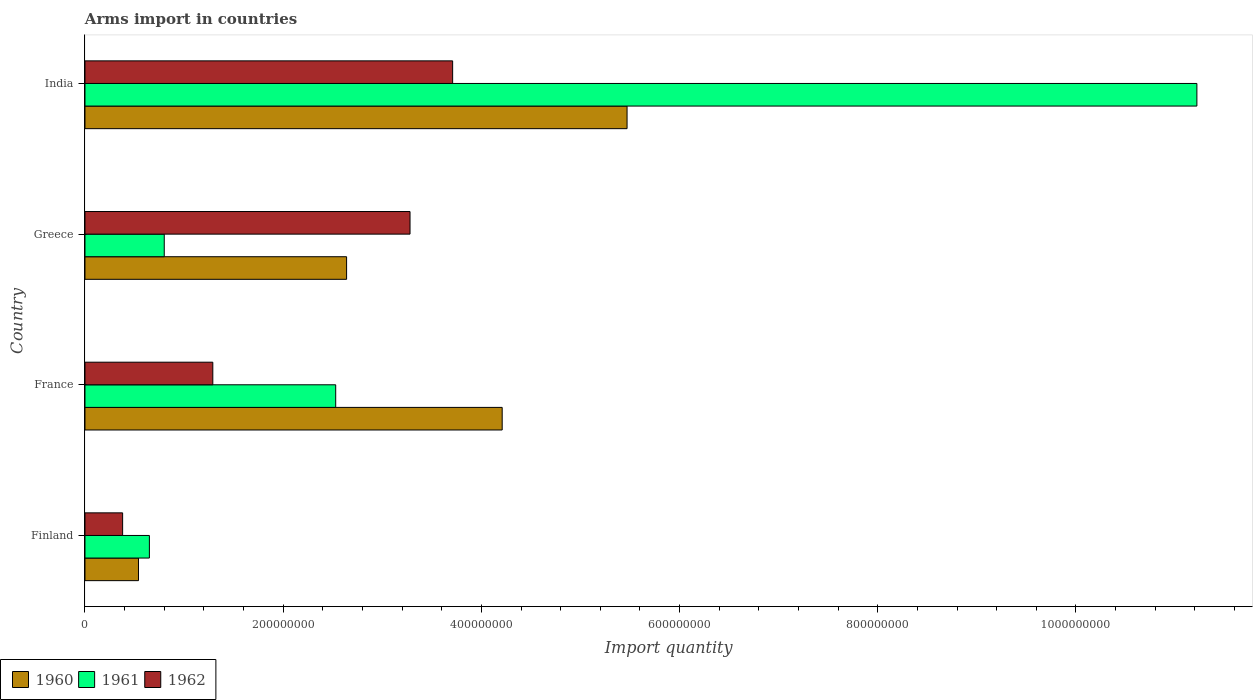How many bars are there on the 4th tick from the bottom?
Make the answer very short. 3. What is the label of the 1st group of bars from the top?
Your answer should be very brief. India. In how many cases, is the number of bars for a given country not equal to the number of legend labels?
Your response must be concise. 0. What is the total arms import in 1960 in France?
Your answer should be very brief. 4.21e+08. Across all countries, what is the maximum total arms import in 1961?
Provide a succinct answer. 1.12e+09. Across all countries, what is the minimum total arms import in 1960?
Offer a very short reply. 5.40e+07. In which country was the total arms import in 1961 minimum?
Offer a terse response. Finland. What is the total total arms import in 1961 in the graph?
Offer a very short reply. 1.52e+09. What is the difference between the total arms import in 1960 in Finland and that in Greece?
Give a very brief answer. -2.10e+08. What is the difference between the total arms import in 1962 in India and the total arms import in 1961 in Finland?
Offer a terse response. 3.06e+08. What is the average total arms import in 1960 per country?
Ensure brevity in your answer.  3.22e+08. What is the difference between the total arms import in 1961 and total arms import in 1962 in France?
Your answer should be compact. 1.24e+08. In how many countries, is the total arms import in 1960 greater than 680000000 ?
Offer a terse response. 0. What is the ratio of the total arms import in 1960 in France to that in India?
Your answer should be compact. 0.77. Is the difference between the total arms import in 1961 in France and India greater than the difference between the total arms import in 1962 in France and India?
Keep it short and to the point. No. What is the difference between the highest and the second highest total arms import in 1961?
Your response must be concise. 8.69e+08. What is the difference between the highest and the lowest total arms import in 1961?
Give a very brief answer. 1.06e+09. What does the 1st bar from the top in Finland represents?
Provide a succinct answer. 1962. What does the 3rd bar from the bottom in Greece represents?
Make the answer very short. 1962. Are all the bars in the graph horizontal?
Ensure brevity in your answer.  Yes. What is the difference between two consecutive major ticks on the X-axis?
Keep it short and to the point. 2.00e+08. Are the values on the major ticks of X-axis written in scientific E-notation?
Your answer should be very brief. No. Does the graph contain any zero values?
Your answer should be very brief. No. Does the graph contain grids?
Your response must be concise. No. Where does the legend appear in the graph?
Keep it short and to the point. Bottom left. How many legend labels are there?
Offer a terse response. 3. What is the title of the graph?
Your response must be concise. Arms import in countries. Does "1963" appear as one of the legend labels in the graph?
Your answer should be compact. No. What is the label or title of the X-axis?
Your answer should be very brief. Import quantity. What is the label or title of the Y-axis?
Offer a terse response. Country. What is the Import quantity in 1960 in Finland?
Provide a short and direct response. 5.40e+07. What is the Import quantity in 1961 in Finland?
Ensure brevity in your answer.  6.50e+07. What is the Import quantity of 1962 in Finland?
Your answer should be very brief. 3.80e+07. What is the Import quantity of 1960 in France?
Keep it short and to the point. 4.21e+08. What is the Import quantity of 1961 in France?
Make the answer very short. 2.53e+08. What is the Import quantity in 1962 in France?
Provide a short and direct response. 1.29e+08. What is the Import quantity of 1960 in Greece?
Your answer should be very brief. 2.64e+08. What is the Import quantity in 1961 in Greece?
Make the answer very short. 8.00e+07. What is the Import quantity in 1962 in Greece?
Offer a terse response. 3.28e+08. What is the Import quantity in 1960 in India?
Your response must be concise. 5.47e+08. What is the Import quantity of 1961 in India?
Your answer should be very brief. 1.12e+09. What is the Import quantity in 1962 in India?
Keep it short and to the point. 3.71e+08. Across all countries, what is the maximum Import quantity of 1960?
Offer a very short reply. 5.47e+08. Across all countries, what is the maximum Import quantity of 1961?
Provide a succinct answer. 1.12e+09. Across all countries, what is the maximum Import quantity in 1962?
Provide a succinct answer. 3.71e+08. Across all countries, what is the minimum Import quantity of 1960?
Provide a short and direct response. 5.40e+07. Across all countries, what is the minimum Import quantity of 1961?
Ensure brevity in your answer.  6.50e+07. Across all countries, what is the minimum Import quantity in 1962?
Keep it short and to the point. 3.80e+07. What is the total Import quantity in 1960 in the graph?
Your answer should be compact. 1.29e+09. What is the total Import quantity in 1961 in the graph?
Offer a very short reply. 1.52e+09. What is the total Import quantity of 1962 in the graph?
Offer a terse response. 8.66e+08. What is the difference between the Import quantity in 1960 in Finland and that in France?
Make the answer very short. -3.67e+08. What is the difference between the Import quantity in 1961 in Finland and that in France?
Your response must be concise. -1.88e+08. What is the difference between the Import quantity in 1962 in Finland and that in France?
Provide a succinct answer. -9.10e+07. What is the difference between the Import quantity in 1960 in Finland and that in Greece?
Keep it short and to the point. -2.10e+08. What is the difference between the Import quantity of 1961 in Finland and that in Greece?
Provide a succinct answer. -1.50e+07. What is the difference between the Import quantity of 1962 in Finland and that in Greece?
Provide a short and direct response. -2.90e+08. What is the difference between the Import quantity in 1960 in Finland and that in India?
Provide a succinct answer. -4.93e+08. What is the difference between the Import quantity in 1961 in Finland and that in India?
Your response must be concise. -1.06e+09. What is the difference between the Import quantity of 1962 in Finland and that in India?
Ensure brevity in your answer.  -3.33e+08. What is the difference between the Import quantity of 1960 in France and that in Greece?
Make the answer very short. 1.57e+08. What is the difference between the Import quantity of 1961 in France and that in Greece?
Keep it short and to the point. 1.73e+08. What is the difference between the Import quantity of 1962 in France and that in Greece?
Ensure brevity in your answer.  -1.99e+08. What is the difference between the Import quantity of 1960 in France and that in India?
Provide a succinct answer. -1.26e+08. What is the difference between the Import quantity of 1961 in France and that in India?
Keep it short and to the point. -8.69e+08. What is the difference between the Import quantity of 1962 in France and that in India?
Provide a succinct answer. -2.42e+08. What is the difference between the Import quantity in 1960 in Greece and that in India?
Provide a succinct answer. -2.83e+08. What is the difference between the Import quantity in 1961 in Greece and that in India?
Give a very brief answer. -1.04e+09. What is the difference between the Import quantity of 1962 in Greece and that in India?
Offer a terse response. -4.30e+07. What is the difference between the Import quantity in 1960 in Finland and the Import quantity in 1961 in France?
Ensure brevity in your answer.  -1.99e+08. What is the difference between the Import quantity in 1960 in Finland and the Import quantity in 1962 in France?
Offer a terse response. -7.50e+07. What is the difference between the Import quantity in 1961 in Finland and the Import quantity in 1962 in France?
Ensure brevity in your answer.  -6.40e+07. What is the difference between the Import quantity in 1960 in Finland and the Import quantity in 1961 in Greece?
Ensure brevity in your answer.  -2.60e+07. What is the difference between the Import quantity of 1960 in Finland and the Import quantity of 1962 in Greece?
Keep it short and to the point. -2.74e+08. What is the difference between the Import quantity in 1961 in Finland and the Import quantity in 1962 in Greece?
Keep it short and to the point. -2.63e+08. What is the difference between the Import quantity in 1960 in Finland and the Import quantity in 1961 in India?
Keep it short and to the point. -1.07e+09. What is the difference between the Import quantity of 1960 in Finland and the Import quantity of 1962 in India?
Provide a succinct answer. -3.17e+08. What is the difference between the Import quantity of 1961 in Finland and the Import quantity of 1962 in India?
Your answer should be compact. -3.06e+08. What is the difference between the Import quantity in 1960 in France and the Import quantity in 1961 in Greece?
Make the answer very short. 3.41e+08. What is the difference between the Import quantity of 1960 in France and the Import quantity of 1962 in Greece?
Your answer should be compact. 9.30e+07. What is the difference between the Import quantity in 1961 in France and the Import quantity in 1962 in Greece?
Provide a short and direct response. -7.50e+07. What is the difference between the Import quantity of 1960 in France and the Import quantity of 1961 in India?
Keep it short and to the point. -7.01e+08. What is the difference between the Import quantity of 1960 in France and the Import quantity of 1962 in India?
Provide a short and direct response. 5.00e+07. What is the difference between the Import quantity of 1961 in France and the Import quantity of 1962 in India?
Your response must be concise. -1.18e+08. What is the difference between the Import quantity of 1960 in Greece and the Import quantity of 1961 in India?
Offer a very short reply. -8.58e+08. What is the difference between the Import quantity of 1960 in Greece and the Import quantity of 1962 in India?
Ensure brevity in your answer.  -1.07e+08. What is the difference between the Import quantity of 1961 in Greece and the Import quantity of 1962 in India?
Make the answer very short. -2.91e+08. What is the average Import quantity of 1960 per country?
Your answer should be compact. 3.22e+08. What is the average Import quantity in 1961 per country?
Offer a terse response. 3.80e+08. What is the average Import quantity of 1962 per country?
Provide a short and direct response. 2.16e+08. What is the difference between the Import quantity in 1960 and Import quantity in 1961 in Finland?
Make the answer very short. -1.10e+07. What is the difference between the Import quantity of 1960 and Import quantity of 1962 in Finland?
Provide a short and direct response. 1.60e+07. What is the difference between the Import quantity of 1961 and Import quantity of 1962 in Finland?
Provide a short and direct response. 2.70e+07. What is the difference between the Import quantity in 1960 and Import quantity in 1961 in France?
Your answer should be very brief. 1.68e+08. What is the difference between the Import quantity of 1960 and Import quantity of 1962 in France?
Your answer should be very brief. 2.92e+08. What is the difference between the Import quantity in 1961 and Import quantity in 1962 in France?
Your answer should be compact. 1.24e+08. What is the difference between the Import quantity of 1960 and Import quantity of 1961 in Greece?
Offer a terse response. 1.84e+08. What is the difference between the Import quantity in 1960 and Import quantity in 1962 in Greece?
Keep it short and to the point. -6.40e+07. What is the difference between the Import quantity of 1961 and Import quantity of 1962 in Greece?
Your answer should be very brief. -2.48e+08. What is the difference between the Import quantity of 1960 and Import quantity of 1961 in India?
Offer a very short reply. -5.75e+08. What is the difference between the Import quantity of 1960 and Import quantity of 1962 in India?
Provide a short and direct response. 1.76e+08. What is the difference between the Import quantity in 1961 and Import quantity in 1962 in India?
Offer a terse response. 7.51e+08. What is the ratio of the Import quantity in 1960 in Finland to that in France?
Give a very brief answer. 0.13. What is the ratio of the Import quantity of 1961 in Finland to that in France?
Offer a terse response. 0.26. What is the ratio of the Import quantity of 1962 in Finland to that in France?
Offer a very short reply. 0.29. What is the ratio of the Import quantity in 1960 in Finland to that in Greece?
Keep it short and to the point. 0.2. What is the ratio of the Import quantity of 1961 in Finland to that in Greece?
Offer a terse response. 0.81. What is the ratio of the Import quantity in 1962 in Finland to that in Greece?
Make the answer very short. 0.12. What is the ratio of the Import quantity in 1960 in Finland to that in India?
Give a very brief answer. 0.1. What is the ratio of the Import quantity of 1961 in Finland to that in India?
Your response must be concise. 0.06. What is the ratio of the Import quantity in 1962 in Finland to that in India?
Your answer should be compact. 0.1. What is the ratio of the Import quantity of 1960 in France to that in Greece?
Ensure brevity in your answer.  1.59. What is the ratio of the Import quantity of 1961 in France to that in Greece?
Provide a succinct answer. 3.16. What is the ratio of the Import quantity of 1962 in France to that in Greece?
Keep it short and to the point. 0.39. What is the ratio of the Import quantity of 1960 in France to that in India?
Your answer should be compact. 0.77. What is the ratio of the Import quantity of 1961 in France to that in India?
Make the answer very short. 0.23. What is the ratio of the Import quantity in 1962 in France to that in India?
Provide a short and direct response. 0.35. What is the ratio of the Import quantity of 1960 in Greece to that in India?
Provide a succinct answer. 0.48. What is the ratio of the Import quantity of 1961 in Greece to that in India?
Make the answer very short. 0.07. What is the ratio of the Import quantity of 1962 in Greece to that in India?
Offer a terse response. 0.88. What is the difference between the highest and the second highest Import quantity of 1960?
Make the answer very short. 1.26e+08. What is the difference between the highest and the second highest Import quantity in 1961?
Ensure brevity in your answer.  8.69e+08. What is the difference between the highest and the second highest Import quantity in 1962?
Your answer should be compact. 4.30e+07. What is the difference between the highest and the lowest Import quantity in 1960?
Your answer should be very brief. 4.93e+08. What is the difference between the highest and the lowest Import quantity of 1961?
Your response must be concise. 1.06e+09. What is the difference between the highest and the lowest Import quantity of 1962?
Your answer should be compact. 3.33e+08. 